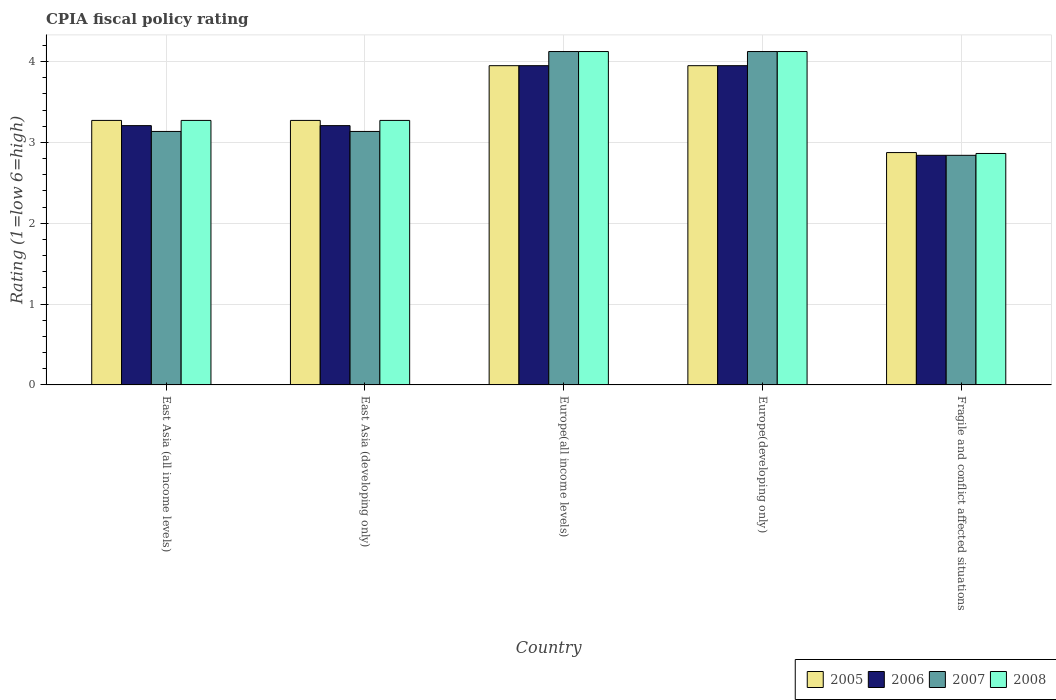How many different coloured bars are there?
Make the answer very short. 4. Are the number of bars on each tick of the X-axis equal?
Make the answer very short. Yes. How many bars are there on the 3rd tick from the left?
Provide a succinct answer. 4. How many bars are there on the 4th tick from the right?
Make the answer very short. 4. What is the label of the 2nd group of bars from the left?
Offer a terse response. East Asia (developing only). What is the CPIA rating in 2008 in Europe(all income levels)?
Provide a short and direct response. 4.12. Across all countries, what is the maximum CPIA rating in 2007?
Ensure brevity in your answer.  4.12. Across all countries, what is the minimum CPIA rating in 2007?
Provide a succinct answer. 2.84. In which country was the CPIA rating in 2005 maximum?
Provide a short and direct response. Europe(all income levels). In which country was the CPIA rating in 2006 minimum?
Keep it short and to the point. Fragile and conflict affected situations. What is the total CPIA rating in 2008 in the graph?
Give a very brief answer. 17.66. What is the difference between the CPIA rating in 2007 in East Asia (developing only) and that in Europe(developing only)?
Your response must be concise. -0.99. What is the difference between the CPIA rating in 2005 in East Asia (developing only) and the CPIA rating in 2007 in Europe(all income levels)?
Your answer should be compact. -0.85. What is the average CPIA rating in 2007 per country?
Offer a very short reply. 3.47. What is the difference between the CPIA rating of/in 2005 and CPIA rating of/in 2007 in Fragile and conflict affected situations?
Keep it short and to the point. 0.03. What is the ratio of the CPIA rating in 2008 in East Asia (developing only) to that in Europe(all income levels)?
Your answer should be very brief. 0.79. Is the CPIA rating in 2005 in East Asia (developing only) less than that in Europe(all income levels)?
Offer a terse response. Yes. What is the difference between the highest and the second highest CPIA rating in 2006?
Make the answer very short. -0.74. What is the difference between the highest and the lowest CPIA rating in 2005?
Keep it short and to the point. 1.08. What does the 4th bar from the left in Europe(developing only) represents?
Your response must be concise. 2008. What does the 1st bar from the right in East Asia (all income levels) represents?
Your response must be concise. 2008. What is the difference between two consecutive major ticks on the Y-axis?
Your response must be concise. 1. Are the values on the major ticks of Y-axis written in scientific E-notation?
Ensure brevity in your answer.  No. Does the graph contain any zero values?
Your answer should be compact. No. Does the graph contain grids?
Your answer should be compact. Yes. How many legend labels are there?
Your answer should be compact. 4. What is the title of the graph?
Keep it short and to the point. CPIA fiscal policy rating. Does "2001" appear as one of the legend labels in the graph?
Your answer should be very brief. No. What is the Rating (1=low 6=high) of 2005 in East Asia (all income levels)?
Offer a very short reply. 3.27. What is the Rating (1=low 6=high) of 2006 in East Asia (all income levels)?
Your answer should be very brief. 3.21. What is the Rating (1=low 6=high) of 2007 in East Asia (all income levels)?
Give a very brief answer. 3.14. What is the Rating (1=low 6=high) of 2008 in East Asia (all income levels)?
Ensure brevity in your answer.  3.27. What is the Rating (1=low 6=high) in 2005 in East Asia (developing only)?
Make the answer very short. 3.27. What is the Rating (1=low 6=high) in 2006 in East Asia (developing only)?
Ensure brevity in your answer.  3.21. What is the Rating (1=low 6=high) of 2007 in East Asia (developing only)?
Make the answer very short. 3.14. What is the Rating (1=low 6=high) in 2008 in East Asia (developing only)?
Your answer should be compact. 3.27. What is the Rating (1=low 6=high) of 2005 in Europe(all income levels)?
Give a very brief answer. 3.95. What is the Rating (1=low 6=high) in 2006 in Europe(all income levels)?
Your answer should be very brief. 3.95. What is the Rating (1=low 6=high) of 2007 in Europe(all income levels)?
Keep it short and to the point. 4.12. What is the Rating (1=low 6=high) in 2008 in Europe(all income levels)?
Ensure brevity in your answer.  4.12. What is the Rating (1=low 6=high) of 2005 in Europe(developing only)?
Your answer should be very brief. 3.95. What is the Rating (1=low 6=high) of 2006 in Europe(developing only)?
Give a very brief answer. 3.95. What is the Rating (1=low 6=high) of 2007 in Europe(developing only)?
Provide a succinct answer. 4.12. What is the Rating (1=low 6=high) of 2008 in Europe(developing only)?
Your answer should be compact. 4.12. What is the Rating (1=low 6=high) in 2005 in Fragile and conflict affected situations?
Your response must be concise. 2.88. What is the Rating (1=low 6=high) of 2006 in Fragile and conflict affected situations?
Provide a short and direct response. 2.84. What is the Rating (1=low 6=high) in 2007 in Fragile and conflict affected situations?
Make the answer very short. 2.84. What is the Rating (1=low 6=high) in 2008 in Fragile and conflict affected situations?
Give a very brief answer. 2.86. Across all countries, what is the maximum Rating (1=low 6=high) in 2005?
Give a very brief answer. 3.95. Across all countries, what is the maximum Rating (1=low 6=high) in 2006?
Provide a succinct answer. 3.95. Across all countries, what is the maximum Rating (1=low 6=high) of 2007?
Give a very brief answer. 4.12. Across all countries, what is the maximum Rating (1=low 6=high) in 2008?
Ensure brevity in your answer.  4.12. Across all countries, what is the minimum Rating (1=low 6=high) of 2005?
Your answer should be very brief. 2.88. Across all countries, what is the minimum Rating (1=low 6=high) in 2006?
Offer a very short reply. 2.84. Across all countries, what is the minimum Rating (1=low 6=high) in 2007?
Give a very brief answer. 2.84. Across all countries, what is the minimum Rating (1=low 6=high) in 2008?
Make the answer very short. 2.86. What is the total Rating (1=low 6=high) in 2005 in the graph?
Offer a very short reply. 17.32. What is the total Rating (1=low 6=high) in 2006 in the graph?
Offer a terse response. 17.16. What is the total Rating (1=low 6=high) of 2007 in the graph?
Ensure brevity in your answer.  17.36. What is the total Rating (1=low 6=high) of 2008 in the graph?
Provide a short and direct response. 17.66. What is the difference between the Rating (1=low 6=high) of 2007 in East Asia (all income levels) and that in East Asia (developing only)?
Provide a short and direct response. 0. What is the difference between the Rating (1=low 6=high) of 2008 in East Asia (all income levels) and that in East Asia (developing only)?
Give a very brief answer. 0. What is the difference between the Rating (1=low 6=high) in 2005 in East Asia (all income levels) and that in Europe(all income levels)?
Keep it short and to the point. -0.68. What is the difference between the Rating (1=low 6=high) of 2006 in East Asia (all income levels) and that in Europe(all income levels)?
Give a very brief answer. -0.74. What is the difference between the Rating (1=low 6=high) in 2007 in East Asia (all income levels) and that in Europe(all income levels)?
Your answer should be very brief. -0.99. What is the difference between the Rating (1=low 6=high) in 2008 in East Asia (all income levels) and that in Europe(all income levels)?
Offer a terse response. -0.85. What is the difference between the Rating (1=low 6=high) in 2005 in East Asia (all income levels) and that in Europe(developing only)?
Provide a short and direct response. -0.68. What is the difference between the Rating (1=low 6=high) of 2006 in East Asia (all income levels) and that in Europe(developing only)?
Make the answer very short. -0.74. What is the difference between the Rating (1=low 6=high) of 2007 in East Asia (all income levels) and that in Europe(developing only)?
Ensure brevity in your answer.  -0.99. What is the difference between the Rating (1=low 6=high) of 2008 in East Asia (all income levels) and that in Europe(developing only)?
Provide a succinct answer. -0.85. What is the difference between the Rating (1=low 6=high) in 2005 in East Asia (all income levels) and that in Fragile and conflict affected situations?
Provide a succinct answer. 0.4. What is the difference between the Rating (1=low 6=high) in 2006 in East Asia (all income levels) and that in Fragile and conflict affected situations?
Provide a succinct answer. 0.37. What is the difference between the Rating (1=low 6=high) in 2007 in East Asia (all income levels) and that in Fragile and conflict affected situations?
Your answer should be compact. 0.3. What is the difference between the Rating (1=low 6=high) of 2008 in East Asia (all income levels) and that in Fragile and conflict affected situations?
Ensure brevity in your answer.  0.41. What is the difference between the Rating (1=low 6=high) of 2005 in East Asia (developing only) and that in Europe(all income levels)?
Provide a short and direct response. -0.68. What is the difference between the Rating (1=low 6=high) in 2006 in East Asia (developing only) and that in Europe(all income levels)?
Your answer should be compact. -0.74. What is the difference between the Rating (1=low 6=high) of 2007 in East Asia (developing only) and that in Europe(all income levels)?
Provide a short and direct response. -0.99. What is the difference between the Rating (1=low 6=high) of 2008 in East Asia (developing only) and that in Europe(all income levels)?
Give a very brief answer. -0.85. What is the difference between the Rating (1=low 6=high) of 2005 in East Asia (developing only) and that in Europe(developing only)?
Your answer should be very brief. -0.68. What is the difference between the Rating (1=low 6=high) of 2006 in East Asia (developing only) and that in Europe(developing only)?
Ensure brevity in your answer.  -0.74. What is the difference between the Rating (1=low 6=high) of 2007 in East Asia (developing only) and that in Europe(developing only)?
Ensure brevity in your answer.  -0.99. What is the difference between the Rating (1=low 6=high) in 2008 in East Asia (developing only) and that in Europe(developing only)?
Your answer should be compact. -0.85. What is the difference between the Rating (1=low 6=high) of 2005 in East Asia (developing only) and that in Fragile and conflict affected situations?
Make the answer very short. 0.4. What is the difference between the Rating (1=low 6=high) in 2006 in East Asia (developing only) and that in Fragile and conflict affected situations?
Give a very brief answer. 0.37. What is the difference between the Rating (1=low 6=high) of 2007 in East Asia (developing only) and that in Fragile and conflict affected situations?
Your answer should be very brief. 0.3. What is the difference between the Rating (1=low 6=high) of 2008 in East Asia (developing only) and that in Fragile and conflict affected situations?
Provide a short and direct response. 0.41. What is the difference between the Rating (1=low 6=high) of 2005 in Europe(all income levels) and that in Europe(developing only)?
Keep it short and to the point. 0. What is the difference between the Rating (1=low 6=high) of 2006 in Europe(all income levels) and that in Europe(developing only)?
Your answer should be compact. 0. What is the difference between the Rating (1=low 6=high) of 2008 in Europe(all income levels) and that in Europe(developing only)?
Your answer should be very brief. 0. What is the difference between the Rating (1=low 6=high) of 2005 in Europe(all income levels) and that in Fragile and conflict affected situations?
Offer a very short reply. 1.07. What is the difference between the Rating (1=low 6=high) of 2006 in Europe(all income levels) and that in Fragile and conflict affected situations?
Keep it short and to the point. 1.11. What is the difference between the Rating (1=low 6=high) of 2007 in Europe(all income levels) and that in Fragile and conflict affected situations?
Provide a short and direct response. 1.28. What is the difference between the Rating (1=low 6=high) in 2008 in Europe(all income levels) and that in Fragile and conflict affected situations?
Provide a succinct answer. 1.26. What is the difference between the Rating (1=low 6=high) in 2005 in Europe(developing only) and that in Fragile and conflict affected situations?
Keep it short and to the point. 1.07. What is the difference between the Rating (1=low 6=high) of 2006 in Europe(developing only) and that in Fragile and conflict affected situations?
Give a very brief answer. 1.11. What is the difference between the Rating (1=low 6=high) in 2007 in Europe(developing only) and that in Fragile and conflict affected situations?
Give a very brief answer. 1.28. What is the difference between the Rating (1=low 6=high) in 2008 in Europe(developing only) and that in Fragile and conflict affected situations?
Give a very brief answer. 1.26. What is the difference between the Rating (1=low 6=high) in 2005 in East Asia (all income levels) and the Rating (1=low 6=high) in 2006 in East Asia (developing only)?
Your answer should be very brief. 0.06. What is the difference between the Rating (1=low 6=high) in 2005 in East Asia (all income levels) and the Rating (1=low 6=high) in 2007 in East Asia (developing only)?
Provide a short and direct response. 0.14. What is the difference between the Rating (1=low 6=high) in 2005 in East Asia (all income levels) and the Rating (1=low 6=high) in 2008 in East Asia (developing only)?
Your response must be concise. 0. What is the difference between the Rating (1=low 6=high) of 2006 in East Asia (all income levels) and the Rating (1=low 6=high) of 2007 in East Asia (developing only)?
Keep it short and to the point. 0.07. What is the difference between the Rating (1=low 6=high) in 2006 in East Asia (all income levels) and the Rating (1=low 6=high) in 2008 in East Asia (developing only)?
Give a very brief answer. -0.06. What is the difference between the Rating (1=low 6=high) in 2007 in East Asia (all income levels) and the Rating (1=low 6=high) in 2008 in East Asia (developing only)?
Keep it short and to the point. -0.14. What is the difference between the Rating (1=low 6=high) of 2005 in East Asia (all income levels) and the Rating (1=low 6=high) of 2006 in Europe(all income levels)?
Your answer should be very brief. -0.68. What is the difference between the Rating (1=low 6=high) in 2005 in East Asia (all income levels) and the Rating (1=low 6=high) in 2007 in Europe(all income levels)?
Offer a terse response. -0.85. What is the difference between the Rating (1=low 6=high) in 2005 in East Asia (all income levels) and the Rating (1=low 6=high) in 2008 in Europe(all income levels)?
Offer a terse response. -0.85. What is the difference between the Rating (1=low 6=high) of 2006 in East Asia (all income levels) and the Rating (1=low 6=high) of 2007 in Europe(all income levels)?
Ensure brevity in your answer.  -0.92. What is the difference between the Rating (1=low 6=high) of 2006 in East Asia (all income levels) and the Rating (1=low 6=high) of 2008 in Europe(all income levels)?
Offer a very short reply. -0.92. What is the difference between the Rating (1=low 6=high) of 2007 in East Asia (all income levels) and the Rating (1=low 6=high) of 2008 in Europe(all income levels)?
Your answer should be compact. -0.99. What is the difference between the Rating (1=low 6=high) in 2005 in East Asia (all income levels) and the Rating (1=low 6=high) in 2006 in Europe(developing only)?
Offer a very short reply. -0.68. What is the difference between the Rating (1=low 6=high) in 2005 in East Asia (all income levels) and the Rating (1=low 6=high) in 2007 in Europe(developing only)?
Provide a succinct answer. -0.85. What is the difference between the Rating (1=low 6=high) in 2005 in East Asia (all income levels) and the Rating (1=low 6=high) in 2008 in Europe(developing only)?
Give a very brief answer. -0.85. What is the difference between the Rating (1=low 6=high) in 2006 in East Asia (all income levels) and the Rating (1=low 6=high) in 2007 in Europe(developing only)?
Your answer should be compact. -0.92. What is the difference between the Rating (1=low 6=high) in 2006 in East Asia (all income levels) and the Rating (1=low 6=high) in 2008 in Europe(developing only)?
Your answer should be very brief. -0.92. What is the difference between the Rating (1=low 6=high) of 2007 in East Asia (all income levels) and the Rating (1=low 6=high) of 2008 in Europe(developing only)?
Ensure brevity in your answer.  -0.99. What is the difference between the Rating (1=low 6=high) in 2005 in East Asia (all income levels) and the Rating (1=low 6=high) in 2006 in Fragile and conflict affected situations?
Keep it short and to the point. 0.43. What is the difference between the Rating (1=low 6=high) in 2005 in East Asia (all income levels) and the Rating (1=low 6=high) in 2007 in Fragile and conflict affected situations?
Offer a very short reply. 0.43. What is the difference between the Rating (1=low 6=high) in 2005 in East Asia (all income levels) and the Rating (1=low 6=high) in 2008 in Fragile and conflict affected situations?
Provide a short and direct response. 0.41. What is the difference between the Rating (1=low 6=high) of 2006 in East Asia (all income levels) and the Rating (1=low 6=high) of 2007 in Fragile and conflict affected situations?
Provide a short and direct response. 0.37. What is the difference between the Rating (1=low 6=high) in 2006 in East Asia (all income levels) and the Rating (1=low 6=high) in 2008 in Fragile and conflict affected situations?
Your response must be concise. 0.34. What is the difference between the Rating (1=low 6=high) in 2007 in East Asia (all income levels) and the Rating (1=low 6=high) in 2008 in Fragile and conflict affected situations?
Keep it short and to the point. 0.27. What is the difference between the Rating (1=low 6=high) in 2005 in East Asia (developing only) and the Rating (1=low 6=high) in 2006 in Europe(all income levels)?
Make the answer very short. -0.68. What is the difference between the Rating (1=low 6=high) in 2005 in East Asia (developing only) and the Rating (1=low 6=high) in 2007 in Europe(all income levels)?
Offer a terse response. -0.85. What is the difference between the Rating (1=low 6=high) in 2005 in East Asia (developing only) and the Rating (1=low 6=high) in 2008 in Europe(all income levels)?
Your answer should be compact. -0.85. What is the difference between the Rating (1=low 6=high) of 2006 in East Asia (developing only) and the Rating (1=low 6=high) of 2007 in Europe(all income levels)?
Provide a succinct answer. -0.92. What is the difference between the Rating (1=low 6=high) of 2006 in East Asia (developing only) and the Rating (1=low 6=high) of 2008 in Europe(all income levels)?
Make the answer very short. -0.92. What is the difference between the Rating (1=low 6=high) of 2007 in East Asia (developing only) and the Rating (1=low 6=high) of 2008 in Europe(all income levels)?
Provide a short and direct response. -0.99. What is the difference between the Rating (1=low 6=high) in 2005 in East Asia (developing only) and the Rating (1=low 6=high) in 2006 in Europe(developing only)?
Offer a terse response. -0.68. What is the difference between the Rating (1=low 6=high) of 2005 in East Asia (developing only) and the Rating (1=low 6=high) of 2007 in Europe(developing only)?
Offer a very short reply. -0.85. What is the difference between the Rating (1=low 6=high) in 2005 in East Asia (developing only) and the Rating (1=low 6=high) in 2008 in Europe(developing only)?
Offer a very short reply. -0.85. What is the difference between the Rating (1=low 6=high) in 2006 in East Asia (developing only) and the Rating (1=low 6=high) in 2007 in Europe(developing only)?
Keep it short and to the point. -0.92. What is the difference between the Rating (1=low 6=high) of 2006 in East Asia (developing only) and the Rating (1=low 6=high) of 2008 in Europe(developing only)?
Offer a very short reply. -0.92. What is the difference between the Rating (1=low 6=high) in 2007 in East Asia (developing only) and the Rating (1=low 6=high) in 2008 in Europe(developing only)?
Offer a very short reply. -0.99. What is the difference between the Rating (1=low 6=high) of 2005 in East Asia (developing only) and the Rating (1=low 6=high) of 2006 in Fragile and conflict affected situations?
Provide a succinct answer. 0.43. What is the difference between the Rating (1=low 6=high) of 2005 in East Asia (developing only) and the Rating (1=low 6=high) of 2007 in Fragile and conflict affected situations?
Ensure brevity in your answer.  0.43. What is the difference between the Rating (1=low 6=high) in 2005 in East Asia (developing only) and the Rating (1=low 6=high) in 2008 in Fragile and conflict affected situations?
Keep it short and to the point. 0.41. What is the difference between the Rating (1=low 6=high) in 2006 in East Asia (developing only) and the Rating (1=low 6=high) in 2007 in Fragile and conflict affected situations?
Your answer should be very brief. 0.37. What is the difference between the Rating (1=low 6=high) in 2006 in East Asia (developing only) and the Rating (1=low 6=high) in 2008 in Fragile and conflict affected situations?
Your answer should be very brief. 0.34. What is the difference between the Rating (1=low 6=high) of 2007 in East Asia (developing only) and the Rating (1=low 6=high) of 2008 in Fragile and conflict affected situations?
Keep it short and to the point. 0.27. What is the difference between the Rating (1=low 6=high) of 2005 in Europe(all income levels) and the Rating (1=low 6=high) of 2006 in Europe(developing only)?
Keep it short and to the point. 0. What is the difference between the Rating (1=low 6=high) in 2005 in Europe(all income levels) and the Rating (1=low 6=high) in 2007 in Europe(developing only)?
Ensure brevity in your answer.  -0.17. What is the difference between the Rating (1=low 6=high) in 2005 in Europe(all income levels) and the Rating (1=low 6=high) in 2008 in Europe(developing only)?
Keep it short and to the point. -0.17. What is the difference between the Rating (1=low 6=high) in 2006 in Europe(all income levels) and the Rating (1=low 6=high) in 2007 in Europe(developing only)?
Your answer should be very brief. -0.17. What is the difference between the Rating (1=low 6=high) of 2006 in Europe(all income levels) and the Rating (1=low 6=high) of 2008 in Europe(developing only)?
Keep it short and to the point. -0.17. What is the difference between the Rating (1=low 6=high) of 2005 in Europe(all income levels) and the Rating (1=low 6=high) of 2006 in Fragile and conflict affected situations?
Offer a very short reply. 1.11. What is the difference between the Rating (1=low 6=high) in 2005 in Europe(all income levels) and the Rating (1=low 6=high) in 2007 in Fragile and conflict affected situations?
Your answer should be very brief. 1.11. What is the difference between the Rating (1=low 6=high) of 2005 in Europe(all income levels) and the Rating (1=low 6=high) of 2008 in Fragile and conflict affected situations?
Your answer should be very brief. 1.09. What is the difference between the Rating (1=low 6=high) of 2006 in Europe(all income levels) and the Rating (1=low 6=high) of 2007 in Fragile and conflict affected situations?
Your answer should be very brief. 1.11. What is the difference between the Rating (1=low 6=high) of 2006 in Europe(all income levels) and the Rating (1=low 6=high) of 2008 in Fragile and conflict affected situations?
Your response must be concise. 1.09. What is the difference between the Rating (1=low 6=high) in 2007 in Europe(all income levels) and the Rating (1=low 6=high) in 2008 in Fragile and conflict affected situations?
Make the answer very short. 1.26. What is the difference between the Rating (1=low 6=high) of 2005 in Europe(developing only) and the Rating (1=low 6=high) of 2006 in Fragile and conflict affected situations?
Your answer should be compact. 1.11. What is the difference between the Rating (1=low 6=high) of 2005 in Europe(developing only) and the Rating (1=low 6=high) of 2007 in Fragile and conflict affected situations?
Your response must be concise. 1.11. What is the difference between the Rating (1=low 6=high) of 2005 in Europe(developing only) and the Rating (1=low 6=high) of 2008 in Fragile and conflict affected situations?
Your answer should be compact. 1.09. What is the difference between the Rating (1=low 6=high) of 2006 in Europe(developing only) and the Rating (1=low 6=high) of 2007 in Fragile and conflict affected situations?
Provide a short and direct response. 1.11. What is the difference between the Rating (1=low 6=high) of 2006 in Europe(developing only) and the Rating (1=low 6=high) of 2008 in Fragile and conflict affected situations?
Offer a terse response. 1.09. What is the difference between the Rating (1=low 6=high) in 2007 in Europe(developing only) and the Rating (1=low 6=high) in 2008 in Fragile and conflict affected situations?
Keep it short and to the point. 1.26. What is the average Rating (1=low 6=high) in 2005 per country?
Make the answer very short. 3.46. What is the average Rating (1=low 6=high) of 2006 per country?
Ensure brevity in your answer.  3.43. What is the average Rating (1=low 6=high) of 2007 per country?
Make the answer very short. 3.47. What is the average Rating (1=low 6=high) in 2008 per country?
Provide a succinct answer. 3.53. What is the difference between the Rating (1=low 6=high) in 2005 and Rating (1=low 6=high) in 2006 in East Asia (all income levels)?
Offer a very short reply. 0.06. What is the difference between the Rating (1=low 6=high) in 2005 and Rating (1=low 6=high) in 2007 in East Asia (all income levels)?
Provide a succinct answer. 0.14. What is the difference between the Rating (1=low 6=high) of 2005 and Rating (1=low 6=high) of 2008 in East Asia (all income levels)?
Ensure brevity in your answer.  0. What is the difference between the Rating (1=low 6=high) of 2006 and Rating (1=low 6=high) of 2007 in East Asia (all income levels)?
Make the answer very short. 0.07. What is the difference between the Rating (1=low 6=high) of 2006 and Rating (1=low 6=high) of 2008 in East Asia (all income levels)?
Your answer should be compact. -0.06. What is the difference between the Rating (1=low 6=high) in 2007 and Rating (1=low 6=high) in 2008 in East Asia (all income levels)?
Provide a short and direct response. -0.14. What is the difference between the Rating (1=low 6=high) of 2005 and Rating (1=low 6=high) of 2006 in East Asia (developing only)?
Offer a terse response. 0.06. What is the difference between the Rating (1=low 6=high) in 2005 and Rating (1=low 6=high) in 2007 in East Asia (developing only)?
Provide a succinct answer. 0.14. What is the difference between the Rating (1=low 6=high) in 2005 and Rating (1=low 6=high) in 2008 in East Asia (developing only)?
Provide a short and direct response. 0. What is the difference between the Rating (1=low 6=high) of 2006 and Rating (1=low 6=high) of 2007 in East Asia (developing only)?
Give a very brief answer. 0.07. What is the difference between the Rating (1=low 6=high) in 2006 and Rating (1=low 6=high) in 2008 in East Asia (developing only)?
Your response must be concise. -0.06. What is the difference between the Rating (1=low 6=high) of 2007 and Rating (1=low 6=high) of 2008 in East Asia (developing only)?
Give a very brief answer. -0.14. What is the difference between the Rating (1=low 6=high) of 2005 and Rating (1=low 6=high) of 2006 in Europe(all income levels)?
Make the answer very short. 0. What is the difference between the Rating (1=low 6=high) in 2005 and Rating (1=low 6=high) in 2007 in Europe(all income levels)?
Your response must be concise. -0.17. What is the difference between the Rating (1=low 6=high) in 2005 and Rating (1=low 6=high) in 2008 in Europe(all income levels)?
Keep it short and to the point. -0.17. What is the difference between the Rating (1=low 6=high) of 2006 and Rating (1=low 6=high) of 2007 in Europe(all income levels)?
Your response must be concise. -0.17. What is the difference between the Rating (1=low 6=high) of 2006 and Rating (1=low 6=high) of 2008 in Europe(all income levels)?
Your answer should be very brief. -0.17. What is the difference between the Rating (1=low 6=high) in 2007 and Rating (1=low 6=high) in 2008 in Europe(all income levels)?
Your answer should be very brief. 0. What is the difference between the Rating (1=low 6=high) in 2005 and Rating (1=low 6=high) in 2007 in Europe(developing only)?
Offer a very short reply. -0.17. What is the difference between the Rating (1=low 6=high) in 2005 and Rating (1=low 6=high) in 2008 in Europe(developing only)?
Offer a terse response. -0.17. What is the difference between the Rating (1=low 6=high) of 2006 and Rating (1=low 6=high) of 2007 in Europe(developing only)?
Provide a succinct answer. -0.17. What is the difference between the Rating (1=low 6=high) in 2006 and Rating (1=low 6=high) in 2008 in Europe(developing only)?
Ensure brevity in your answer.  -0.17. What is the difference between the Rating (1=low 6=high) of 2005 and Rating (1=low 6=high) of 2006 in Fragile and conflict affected situations?
Keep it short and to the point. 0.03. What is the difference between the Rating (1=low 6=high) of 2005 and Rating (1=low 6=high) of 2007 in Fragile and conflict affected situations?
Offer a terse response. 0.03. What is the difference between the Rating (1=low 6=high) of 2005 and Rating (1=low 6=high) of 2008 in Fragile and conflict affected situations?
Your answer should be very brief. 0.01. What is the difference between the Rating (1=low 6=high) of 2006 and Rating (1=low 6=high) of 2007 in Fragile and conflict affected situations?
Offer a terse response. 0. What is the difference between the Rating (1=low 6=high) of 2006 and Rating (1=low 6=high) of 2008 in Fragile and conflict affected situations?
Ensure brevity in your answer.  -0.02. What is the difference between the Rating (1=low 6=high) in 2007 and Rating (1=low 6=high) in 2008 in Fragile and conflict affected situations?
Offer a terse response. -0.02. What is the ratio of the Rating (1=low 6=high) in 2005 in East Asia (all income levels) to that in East Asia (developing only)?
Offer a very short reply. 1. What is the ratio of the Rating (1=low 6=high) in 2007 in East Asia (all income levels) to that in East Asia (developing only)?
Give a very brief answer. 1. What is the ratio of the Rating (1=low 6=high) of 2005 in East Asia (all income levels) to that in Europe(all income levels)?
Make the answer very short. 0.83. What is the ratio of the Rating (1=low 6=high) in 2006 in East Asia (all income levels) to that in Europe(all income levels)?
Offer a very short reply. 0.81. What is the ratio of the Rating (1=low 6=high) in 2007 in East Asia (all income levels) to that in Europe(all income levels)?
Provide a succinct answer. 0.76. What is the ratio of the Rating (1=low 6=high) of 2008 in East Asia (all income levels) to that in Europe(all income levels)?
Offer a terse response. 0.79. What is the ratio of the Rating (1=low 6=high) in 2005 in East Asia (all income levels) to that in Europe(developing only)?
Give a very brief answer. 0.83. What is the ratio of the Rating (1=low 6=high) of 2006 in East Asia (all income levels) to that in Europe(developing only)?
Make the answer very short. 0.81. What is the ratio of the Rating (1=low 6=high) of 2007 in East Asia (all income levels) to that in Europe(developing only)?
Provide a succinct answer. 0.76. What is the ratio of the Rating (1=low 6=high) of 2008 in East Asia (all income levels) to that in Europe(developing only)?
Offer a terse response. 0.79. What is the ratio of the Rating (1=low 6=high) in 2005 in East Asia (all income levels) to that in Fragile and conflict affected situations?
Your answer should be very brief. 1.14. What is the ratio of the Rating (1=low 6=high) of 2006 in East Asia (all income levels) to that in Fragile and conflict affected situations?
Ensure brevity in your answer.  1.13. What is the ratio of the Rating (1=low 6=high) of 2007 in East Asia (all income levels) to that in Fragile and conflict affected situations?
Keep it short and to the point. 1.1. What is the ratio of the Rating (1=low 6=high) in 2005 in East Asia (developing only) to that in Europe(all income levels)?
Your response must be concise. 0.83. What is the ratio of the Rating (1=low 6=high) in 2006 in East Asia (developing only) to that in Europe(all income levels)?
Your answer should be compact. 0.81. What is the ratio of the Rating (1=low 6=high) of 2007 in East Asia (developing only) to that in Europe(all income levels)?
Offer a terse response. 0.76. What is the ratio of the Rating (1=low 6=high) in 2008 in East Asia (developing only) to that in Europe(all income levels)?
Offer a very short reply. 0.79. What is the ratio of the Rating (1=low 6=high) in 2005 in East Asia (developing only) to that in Europe(developing only)?
Your answer should be compact. 0.83. What is the ratio of the Rating (1=low 6=high) of 2006 in East Asia (developing only) to that in Europe(developing only)?
Provide a succinct answer. 0.81. What is the ratio of the Rating (1=low 6=high) of 2007 in East Asia (developing only) to that in Europe(developing only)?
Your answer should be compact. 0.76. What is the ratio of the Rating (1=low 6=high) of 2008 in East Asia (developing only) to that in Europe(developing only)?
Keep it short and to the point. 0.79. What is the ratio of the Rating (1=low 6=high) in 2005 in East Asia (developing only) to that in Fragile and conflict affected situations?
Your answer should be very brief. 1.14. What is the ratio of the Rating (1=low 6=high) of 2006 in East Asia (developing only) to that in Fragile and conflict affected situations?
Provide a succinct answer. 1.13. What is the ratio of the Rating (1=low 6=high) of 2007 in East Asia (developing only) to that in Fragile and conflict affected situations?
Offer a terse response. 1.1. What is the ratio of the Rating (1=low 6=high) in 2008 in East Asia (developing only) to that in Fragile and conflict affected situations?
Your response must be concise. 1.14. What is the ratio of the Rating (1=low 6=high) of 2005 in Europe(all income levels) to that in Europe(developing only)?
Your response must be concise. 1. What is the ratio of the Rating (1=low 6=high) of 2005 in Europe(all income levels) to that in Fragile and conflict affected situations?
Your response must be concise. 1.37. What is the ratio of the Rating (1=low 6=high) in 2006 in Europe(all income levels) to that in Fragile and conflict affected situations?
Your answer should be compact. 1.39. What is the ratio of the Rating (1=low 6=high) of 2007 in Europe(all income levels) to that in Fragile and conflict affected situations?
Keep it short and to the point. 1.45. What is the ratio of the Rating (1=low 6=high) in 2008 in Europe(all income levels) to that in Fragile and conflict affected situations?
Provide a succinct answer. 1.44. What is the ratio of the Rating (1=low 6=high) of 2005 in Europe(developing only) to that in Fragile and conflict affected situations?
Provide a short and direct response. 1.37. What is the ratio of the Rating (1=low 6=high) of 2006 in Europe(developing only) to that in Fragile and conflict affected situations?
Provide a short and direct response. 1.39. What is the ratio of the Rating (1=low 6=high) in 2007 in Europe(developing only) to that in Fragile and conflict affected situations?
Offer a very short reply. 1.45. What is the ratio of the Rating (1=low 6=high) in 2008 in Europe(developing only) to that in Fragile and conflict affected situations?
Offer a very short reply. 1.44. What is the difference between the highest and the second highest Rating (1=low 6=high) of 2005?
Make the answer very short. 0. What is the difference between the highest and the second highest Rating (1=low 6=high) in 2007?
Keep it short and to the point. 0. What is the difference between the highest and the lowest Rating (1=low 6=high) of 2005?
Offer a very short reply. 1.07. What is the difference between the highest and the lowest Rating (1=low 6=high) in 2006?
Provide a succinct answer. 1.11. What is the difference between the highest and the lowest Rating (1=low 6=high) in 2007?
Ensure brevity in your answer.  1.28. What is the difference between the highest and the lowest Rating (1=low 6=high) of 2008?
Give a very brief answer. 1.26. 